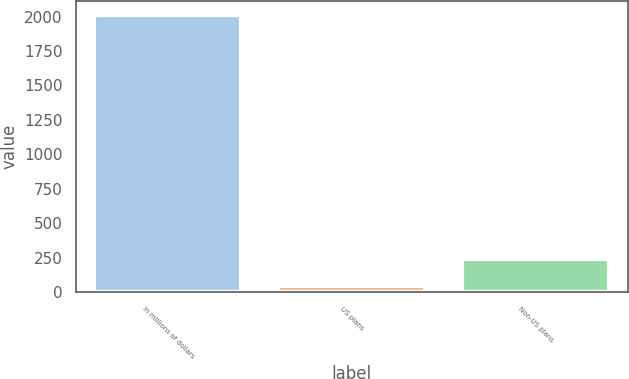Convert chart. <chart><loc_0><loc_0><loc_500><loc_500><bar_chart><fcel>In millions of dollars<fcel>US plans<fcel>Non-US plans<nl><fcel>2015<fcel>44<fcel>241.1<nl></chart> 